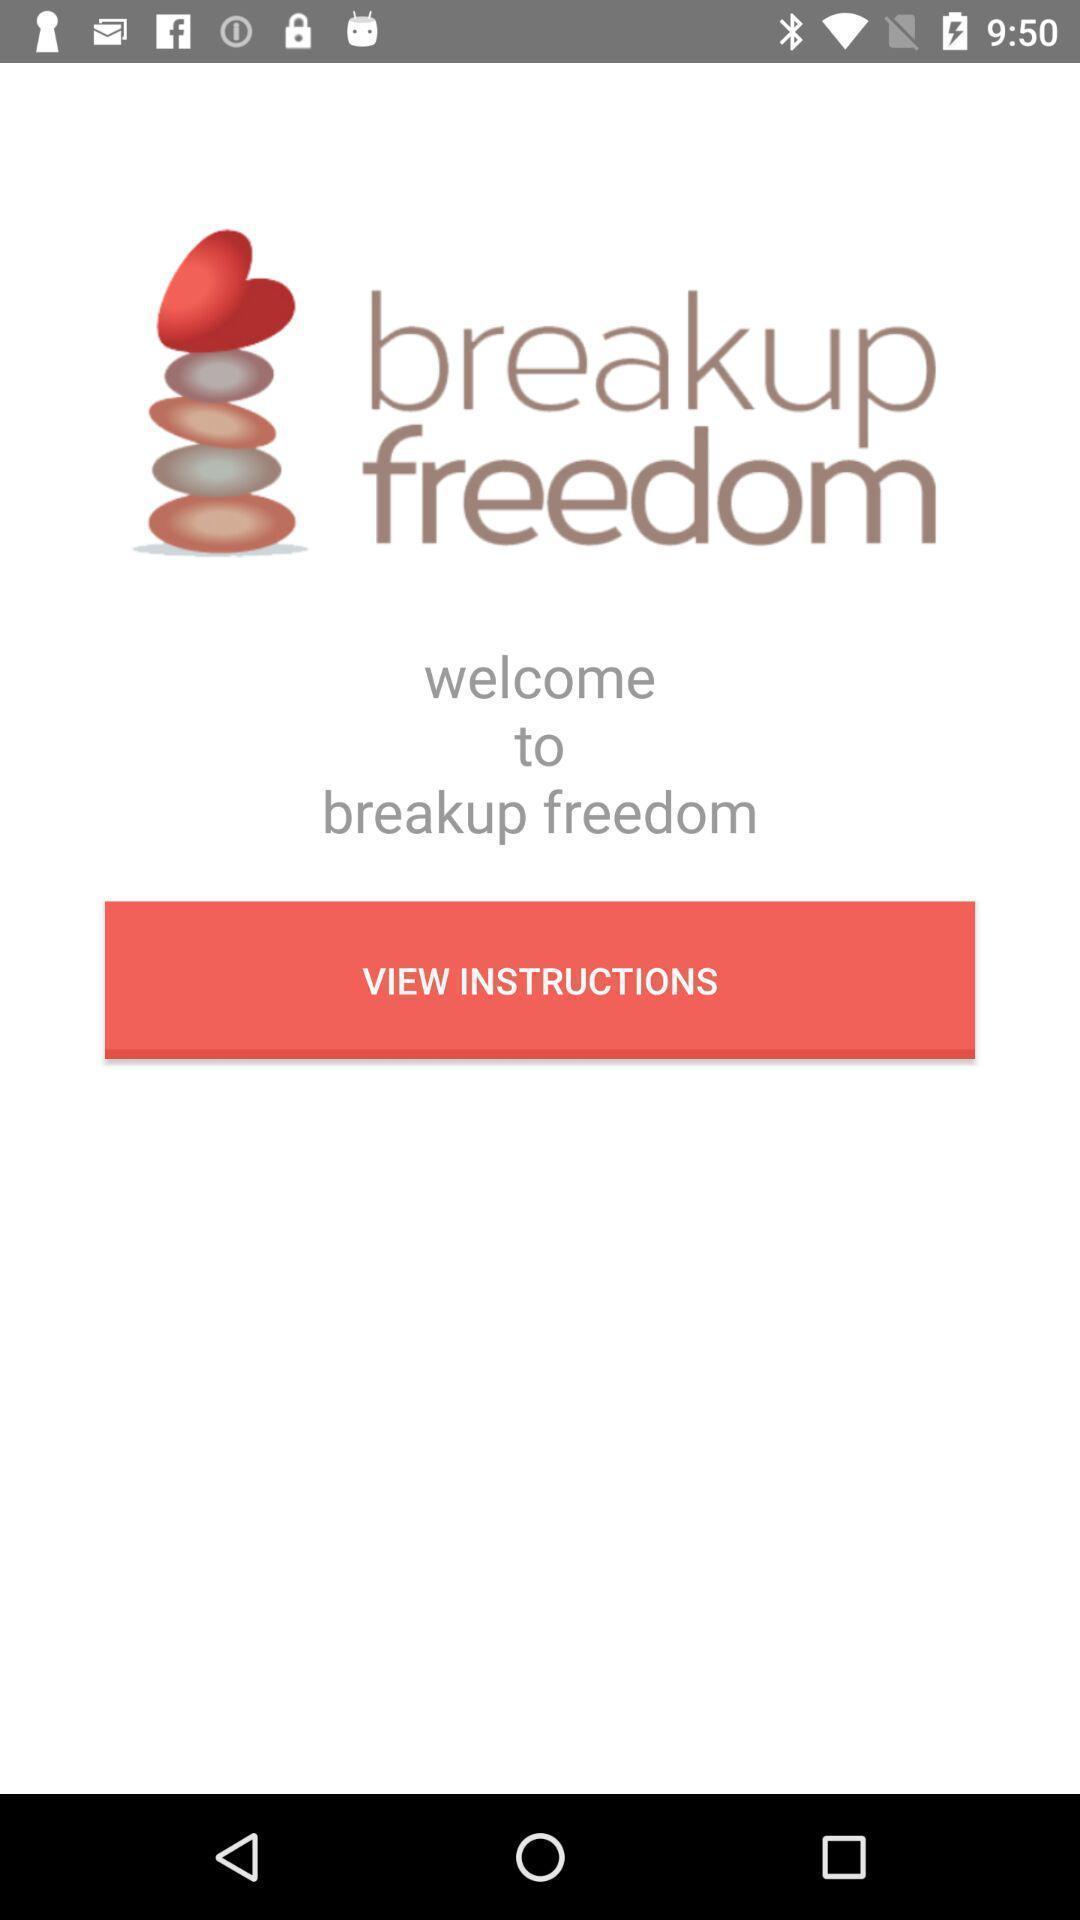Summarize the main components in this picture. Welcome page. 